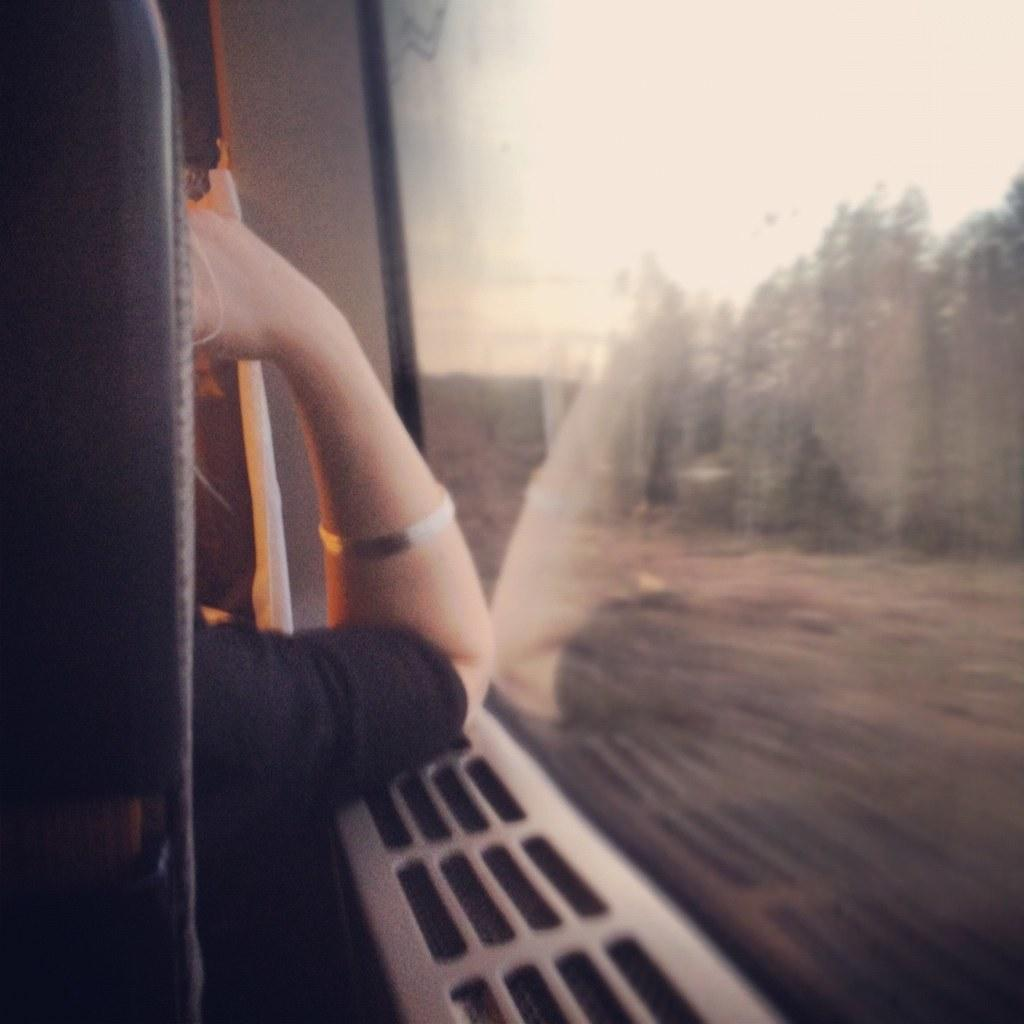What is the person in the image doing? The person is sitting near a glass door in the image. What can be seen through the glass door? Trees are visible through the glass door. What is visible at the top of the image? The sky is visible at the top of the image. How many bikes are parked near the person in the image? There are no bikes visible in the image. What grade does the person in the image have? The image does not provide any information about the person's grade. 